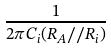<formula> <loc_0><loc_0><loc_500><loc_500>\frac { 1 } { 2 \pi C _ { i } ( R _ { A } / / R _ { i } ) }</formula> 